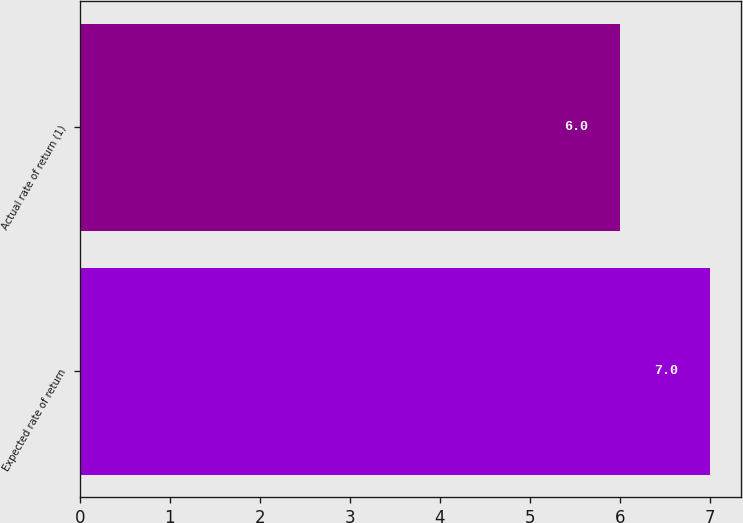Convert chart. <chart><loc_0><loc_0><loc_500><loc_500><bar_chart><fcel>Expected rate of return<fcel>Actual rate of return (1)<nl><fcel>7<fcel>6<nl></chart> 